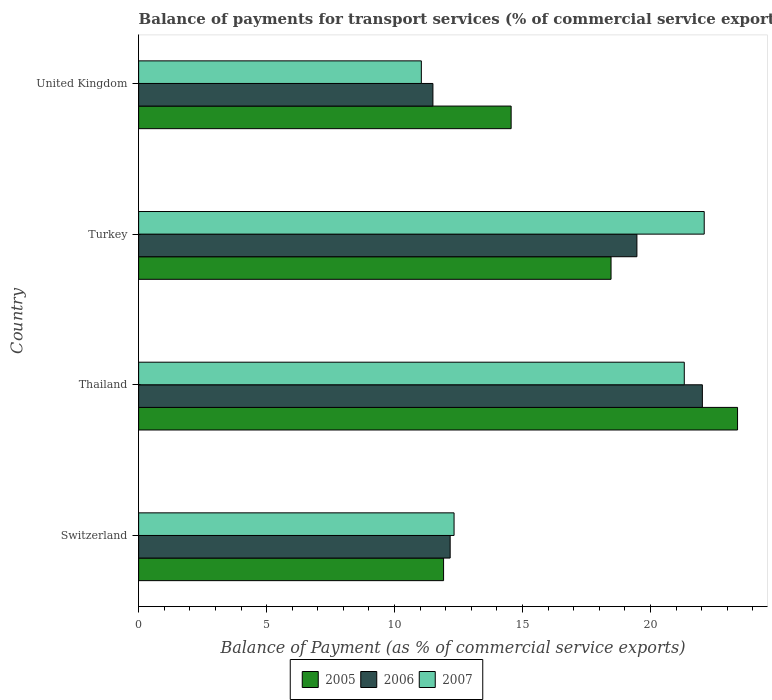How many different coloured bars are there?
Your answer should be compact. 3. Are the number of bars per tick equal to the number of legend labels?
Offer a terse response. Yes. How many bars are there on the 3rd tick from the top?
Ensure brevity in your answer.  3. How many bars are there on the 4th tick from the bottom?
Offer a terse response. 3. What is the label of the 1st group of bars from the top?
Give a very brief answer. United Kingdom. What is the balance of payments for transport services in 2005 in Switzerland?
Give a very brief answer. 11.91. Across all countries, what is the maximum balance of payments for transport services in 2005?
Offer a very short reply. 23.4. Across all countries, what is the minimum balance of payments for transport services in 2006?
Provide a short and direct response. 11.5. In which country was the balance of payments for transport services in 2005 maximum?
Your answer should be compact. Thailand. What is the total balance of payments for transport services in 2006 in the graph?
Your answer should be compact. 65.16. What is the difference between the balance of payments for transport services in 2007 in Switzerland and that in Turkey?
Your answer should be very brief. -9.77. What is the difference between the balance of payments for transport services in 2005 in Thailand and the balance of payments for transport services in 2007 in Switzerland?
Your answer should be very brief. 11.08. What is the average balance of payments for transport services in 2005 per country?
Ensure brevity in your answer.  17.08. What is the difference between the balance of payments for transport services in 2006 and balance of payments for transport services in 2007 in United Kingdom?
Keep it short and to the point. 0.45. What is the ratio of the balance of payments for transport services in 2007 in Switzerland to that in Thailand?
Provide a short and direct response. 0.58. What is the difference between the highest and the second highest balance of payments for transport services in 2006?
Offer a very short reply. 2.56. What is the difference between the highest and the lowest balance of payments for transport services in 2006?
Your answer should be very brief. 10.53. Are all the bars in the graph horizontal?
Offer a very short reply. Yes. Are the values on the major ticks of X-axis written in scientific E-notation?
Give a very brief answer. No. Does the graph contain grids?
Your answer should be compact. No. Where does the legend appear in the graph?
Keep it short and to the point. Bottom center. How are the legend labels stacked?
Make the answer very short. Horizontal. What is the title of the graph?
Your answer should be very brief. Balance of payments for transport services (% of commercial service exports). What is the label or title of the X-axis?
Your answer should be compact. Balance of Payment (as % of commercial service exports). What is the Balance of Payment (as % of commercial service exports) of 2005 in Switzerland?
Your answer should be very brief. 11.91. What is the Balance of Payment (as % of commercial service exports) of 2006 in Switzerland?
Provide a short and direct response. 12.17. What is the Balance of Payment (as % of commercial service exports) in 2007 in Switzerland?
Ensure brevity in your answer.  12.32. What is the Balance of Payment (as % of commercial service exports) in 2005 in Thailand?
Give a very brief answer. 23.4. What is the Balance of Payment (as % of commercial service exports) in 2006 in Thailand?
Your answer should be very brief. 22.03. What is the Balance of Payment (as % of commercial service exports) in 2007 in Thailand?
Provide a succinct answer. 21.32. What is the Balance of Payment (as % of commercial service exports) of 2005 in Turkey?
Offer a very short reply. 18.46. What is the Balance of Payment (as % of commercial service exports) of 2006 in Turkey?
Ensure brevity in your answer.  19.47. What is the Balance of Payment (as % of commercial service exports) of 2007 in Turkey?
Provide a succinct answer. 22.1. What is the Balance of Payment (as % of commercial service exports) in 2005 in United Kingdom?
Provide a succinct answer. 14.55. What is the Balance of Payment (as % of commercial service exports) in 2006 in United Kingdom?
Your response must be concise. 11.5. What is the Balance of Payment (as % of commercial service exports) of 2007 in United Kingdom?
Make the answer very short. 11.05. Across all countries, what is the maximum Balance of Payment (as % of commercial service exports) of 2005?
Offer a terse response. 23.4. Across all countries, what is the maximum Balance of Payment (as % of commercial service exports) in 2006?
Keep it short and to the point. 22.03. Across all countries, what is the maximum Balance of Payment (as % of commercial service exports) in 2007?
Make the answer very short. 22.1. Across all countries, what is the minimum Balance of Payment (as % of commercial service exports) of 2005?
Keep it short and to the point. 11.91. Across all countries, what is the minimum Balance of Payment (as % of commercial service exports) of 2006?
Provide a short and direct response. 11.5. Across all countries, what is the minimum Balance of Payment (as % of commercial service exports) in 2007?
Offer a terse response. 11.05. What is the total Balance of Payment (as % of commercial service exports) of 2005 in the graph?
Give a very brief answer. 68.32. What is the total Balance of Payment (as % of commercial service exports) in 2006 in the graph?
Your response must be concise. 65.16. What is the total Balance of Payment (as % of commercial service exports) in 2007 in the graph?
Ensure brevity in your answer.  66.78. What is the difference between the Balance of Payment (as % of commercial service exports) in 2005 in Switzerland and that in Thailand?
Give a very brief answer. -11.49. What is the difference between the Balance of Payment (as % of commercial service exports) in 2006 in Switzerland and that in Thailand?
Provide a short and direct response. -9.85. What is the difference between the Balance of Payment (as % of commercial service exports) in 2007 in Switzerland and that in Thailand?
Ensure brevity in your answer.  -8.99. What is the difference between the Balance of Payment (as % of commercial service exports) in 2005 in Switzerland and that in Turkey?
Offer a very short reply. -6.54. What is the difference between the Balance of Payment (as % of commercial service exports) in 2006 in Switzerland and that in Turkey?
Your answer should be very brief. -7.3. What is the difference between the Balance of Payment (as % of commercial service exports) in 2007 in Switzerland and that in Turkey?
Offer a very short reply. -9.77. What is the difference between the Balance of Payment (as % of commercial service exports) in 2005 in Switzerland and that in United Kingdom?
Your answer should be compact. -2.64. What is the difference between the Balance of Payment (as % of commercial service exports) in 2006 in Switzerland and that in United Kingdom?
Give a very brief answer. 0.67. What is the difference between the Balance of Payment (as % of commercial service exports) in 2007 in Switzerland and that in United Kingdom?
Make the answer very short. 1.28. What is the difference between the Balance of Payment (as % of commercial service exports) in 2005 in Thailand and that in Turkey?
Provide a short and direct response. 4.94. What is the difference between the Balance of Payment (as % of commercial service exports) of 2006 in Thailand and that in Turkey?
Provide a succinct answer. 2.56. What is the difference between the Balance of Payment (as % of commercial service exports) in 2007 in Thailand and that in Turkey?
Make the answer very short. -0.78. What is the difference between the Balance of Payment (as % of commercial service exports) of 2005 in Thailand and that in United Kingdom?
Ensure brevity in your answer.  8.85. What is the difference between the Balance of Payment (as % of commercial service exports) in 2006 in Thailand and that in United Kingdom?
Ensure brevity in your answer.  10.53. What is the difference between the Balance of Payment (as % of commercial service exports) of 2007 in Thailand and that in United Kingdom?
Provide a succinct answer. 10.27. What is the difference between the Balance of Payment (as % of commercial service exports) in 2005 in Turkey and that in United Kingdom?
Make the answer very short. 3.9. What is the difference between the Balance of Payment (as % of commercial service exports) of 2006 in Turkey and that in United Kingdom?
Your answer should be very brief. 7.97. What is the difference between the Balance of Payment (as % of commercial service exports) of 2007 in Turkey and that in United Kingdom?
Make the answer very short. 11.05. What is the difference between the Balance of Payment (as % of commercial service exports) of 2005 in Switzerland and the Balance of Payment (as % of commercial service exports) of 2006 in Thailand?
Provide a succinct answer. -10.11. What is the difference between the Balance of Payment (as % of commercial service exports) of 2005 in Switzerland and the Balance of Payment (as % of commercial service exports) of 2007 in Thailand?
Provide a short and direct response. -9.4. What is the difference between the Balance of Payment (as % of commercial service exports) in 2006 in Switzerland and the Balance of Payment (as % of commercial service exports) in 2007 in Thailand?
Provide a succinct answer. -9.15. What is the difference between the Balance of Payment (as % of commercial service exports) of 2005 in Switzerland and the Balance of Payment (as % of commercial service exports) of 2006 in Turkey?
Your answer should be compact. -7.55. What is the difference between the Balance of Payment (as % of commercial service exports) in 2005 in Switzerland and the Balance of Payment (as % of commercial service exports) in 2007 in Turkey?
Your answer should be very brief. -10.18. What is the difference between the Balance of Payment (as % of commercial service exports) in 2006 in Switzerland and the Balance of Payment (as % of commercial service exports) in 2007 in Turkey?
Your answer should be very brief. -9.93. What is the difference between the Balance of Payment (as % of commercial service exports) in 2005 in Switzerland and the Balance of Payment (as % of commercial service exports) in 2006 in United Kingdom?
Make the answer very short. 0.42. What is the difference between the Balance of Payment (as % of commercial service exports) of 2005 in Switzerland and the Balance of Payment (as % of commercial service exports) of 2007 in United Kingdom?
Keep it short and to the point. 0.87. What is the difference between the Balance of Payment (as % of commercial service exports) of 2006 in Switzerland and the Balance of Payment (as % of commercial service exports) of 2007 in United Kingdom?
Ensure brevity in your answer.  1.13. What is the difference between the Balance of Payment (as % of commercial service exports) of 2005 in Thailand and the Balance of Payment (as % of commercial service exports) of 2006 in Turkey?
Offer a very short reply. 3.93. What is the difference between the Balance of Payment (as % of commercial service exports) of 2005 in Thailand and the Balance of Payment (as % of commercial service exports) of 2007 in Turkey?
Provide a succinct answer. 1.3. What is the difference between the Balance of Payment (as % of commercial service exports) in 2006 in Thailand and the Balance of Payment (as % of commercial service exports) in 2007 in Turkey?
Keep it short and to the point. -0.07. What is the difference between the Balance of Payment (as % of commercial service exports) in 2005 in Thailand and the Balance of Payment (as % of commercial service exports) in 2006 in United Kingdom?
Provide a succinct answer. 11.9. What is the difference between the Balance of Payment (as % of commercial service exports) in 2005 in Thailand and the Balance of Payment (as % of commercial service exports) in 2007 in United Kingdom?
Ensure brevity in your answer.  12.35. What is the difference between the Balance of Payment (as % of commercial service exports) of 2006 in Thailand and the Balance of Payment (as % of commercial service exports) of 2007 in United Kingdom?
Offer a terse response. 10.98. What is the difference between the Balance of Payment (as % of commercial service exports) in 2005 in Turkey and the Balance of Payment (as % of commercial service exports) in 2006 in United Kingdom?
Give a very brief answer. 6.96. What is the difference between the Balance of Payment (as % of commercial service exports) in 2005 in Turkey and the Balance of Payment (as % of commercial service exports) in 2007 in United Kingdom?
Ensure brevity in your answer.  7.41. What is the difference between the Balance of Payment (as % of commercial service exports) of 2006 in Turkey and the Balance of Payment (as % of commercial service exports) of 2007 in United Kingdom?
Provide a succinct answer. 8.42. What is the average Balance of Payment (as % of commercial service exports) in 2005 per country?
Provide a short and direct response. 17.08. What is the average Balance of Payment (as % of commercial service exports) of 2006 per country?
Your answer should be very brief. 16.29. What is the average Balance of Payment (as % of commercial service exports) of 2007 per country?
Offer a terse response. 16.7. What is the difference between the Balance of Payment (as % of commercial service exports) in 2005 and Balance of Payment (as % of commercial service exports) in 2006 in Switzerland?
Keep it short and to the point. -0.26. What is the difference between the Balance of Payment (as % of commercial service exports) in 2005 and Balance of Payment (as % of commercial service exports) in 2007 in Switzerland?
Make the answer very short. -0.41. What is the difference between the Balance of Payment (as % of commercial service exports) of 2006 and Balance of Payment (as % of commercial service exports) of 2007 in Switzerland?
Your answer should be very brief. -0.15. What is the difference between the Balance of Payment (as % of commercial service exports) in 2005 and Balance of Payment (as % of commercial service exports) in 2006 in Thailand?
Offer a very short reply. 1.37. What is the difference between the Balance of Payment (as % of commercial service exports) of 2005 and Balance of Payment (as % of commercial service exports) of 2007 in Thailand?
Make the answer very short. 2.08. What is the difference between the Balance of Payment (as % of commercial service exports) of 2006 and Balance of Payment (as % of commercial service exports) of 2007 in Thailand?
Your answer should be very brief. 0.71. What is the difference between the Balance of Payment (as % of commercial service exports) of 2005 and Balance of Payment (as % of commercial service exports) of 2006 in Turkey?
Provide a short and direct response. -1.01. What is the difference between the Balance of Payment (as % of commercial service exports) of 2005 and Balance of Payment (as % of commercial service exports) of 2007 in Turkey?
Offer a terse response. -3.64. What is the difference between the Balance of Payment (as % of commercial service exports) of 2006 and Balance of Payment (as % of commercial service exports) of 2007 in Turkey?
Provide a succinct answer. -2.63. What is the difference between the Balance of Payment (as % of commercial service exports) in 2005 and Balance of Payment (as % of commercial service exports) in 2006 in United Kingdom?
Provide a short and direct response. 3.06. What is the difference between the Balance of Payment (as % of commercial service exports) in 2005 and Balance of Payment (as % of commercial service exports) in 2007 in United Kingdom?
Your answer should be very brief. 3.51. What is the difference between the Balance of Payment (as % of commercial service exports) in 2006 and Balance of Payment (as % of commercial service exports) in 2007 in United Kingdom?
Your answer should be compact. 0.45. What is the ratio of the Balance of Payment (as % of commercial service exports) of 2005 in Switzerland to that in Thailand?
Keep it short and to the point. 0.51. What is the ratio of the Balance of Payment (as % of commercial service exports) of 2006 in Switzerland to that in Thailand?
Keep it short and to the point. 0.55. What is the ratio of the Balance of Payment (as % of commercial service exports) in 2007 in Switzerland to that in Thailand?
Provide a succinct answer. 0.58. What is the ratio of the Balance of Payment (as % of commercial service exports) in 2005 in Switzerland to that in Turkey?
Your answer should be very brief. 0.65. What is the ratio of the Balance of Payment (as % of commercial service exports) in 2006 in Switzerland to that in Turkey?
Make the answer very short. 0.63. What is the ratio of the Balance of Payment (as % of commercial service exports) of 2007 in Switzerland to that in Turkey?
Your answer should be compact. 0.56. What is the ratio of the Balance of Payment (as % of commercial service exports) in 2005 in Switzerland to that in United Kingdom?
Provide a succinct answer. 0.82. What is the ratio of the Balance of Payment (as % of commercial service exports) in 2006 in Switzerland to that in United Kingdom?
Ensure brevity in your answer.  1.06. What is the ratio of the Balance of Payment (as % of commercial service exports) in 2007 in Switzerland to that in United Kingdom?
Provide a succinct answer. 1.12. What is the ratio of the Balance of Payment (as % of commercial service exports) of 2005 in Thailand to that in Turkey?
Your response must be concise. 1.27. What is the ratio of the Balance of Payment (as % of commercial service exports) of 2006 in Thailand to that in Turkey?
Provide a short and direct response. 1.13. What is the ratio of the Balance of Payment (as % of commercial service exports) in 2007 in Thailand to that in Turkey?
Offer a very short reply. 0.96. What is the ratio of the Balance of Payment (as % of commercial service exports) of 2005 in Thailand to that in United Kingdom?
Give a very brief answer. 1.61. What is the ratio of the Balance of Payment (as % of commercial service exports) of 2006 in Thailand to that in United Kingdom?
Your answer should be very brief. 1.92. What is the ratio of the Balance of Payment (as % of commercial service exports) in 2007 in Thailand to that in United Kingdom?
Your answer should be very brief. 1.93. What is the ratio of the Balance of Payment (as % of commercial service exports) of 2005 in Turkey to that in United Kingdom?
Offer a very short reply. 1.27. What is the ratio of the Balance of Payment (as % of commercial service exports) of 2006 in Turkey to that in United Kingdom?
Your answer should be very brief. 1.69. What is the ratio of the Balance of Payment (as % of commercial service exports) in 2007 in Turkey to that in United Kingdom?
Provide a short and direct response. 2. What is the difference between the highest and the second highest Balance of Payment (as % of commercial service exports) in 2005?
Your answer should be very brief. 4.94. What is the difference between the highest and the second highest Balance of Payment (as % of commercial service exports) of 2006?
Offer a very short reply. 2.56. What is the difference between the highest and the second highest Balance of Payment (as % of commercial service exports) of 2007?
Offer a very short reply. 0.78. What is the difference between the highest and the lowest Balance of Payment (as % of commercial service exports) of 2005?
Provide a short and direct response. 11.49. What is the difference between the highest and the lowest Balance of Payment (as % of commercial service exports) in 2006?
Offer a very short reply. 10.53. What is the difference between the highest and the lowest Balance of Payment (as % of commercial service exports) in 2007?
Provide a short and direct response. 11.05. 